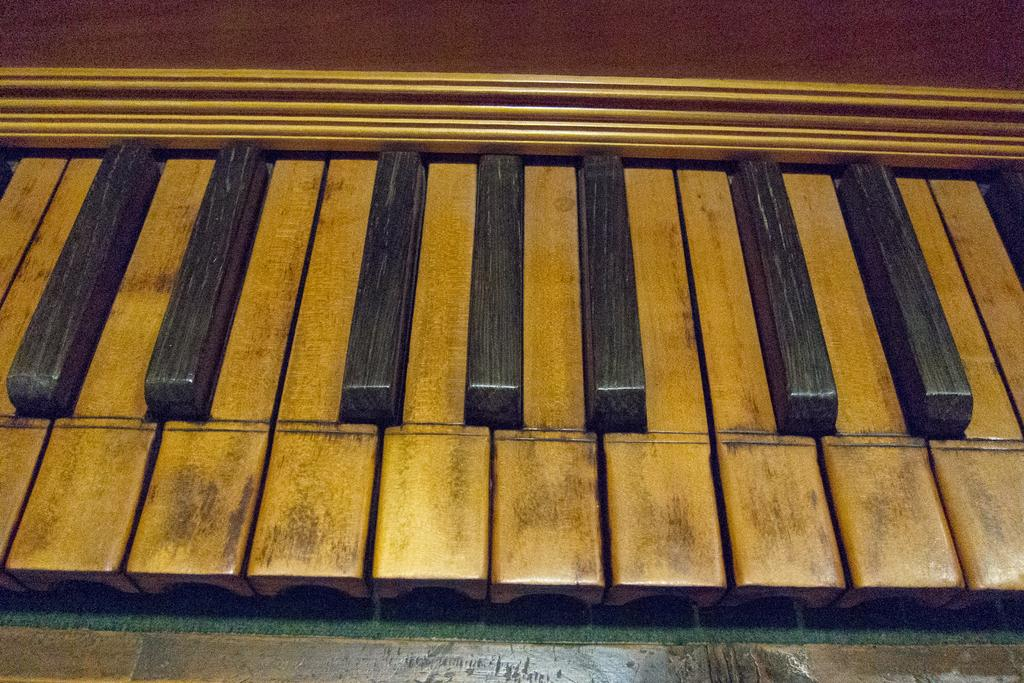What musical instrument can be seen in the image? There is a piano in the image. What material is the piano made of? The piano is made of wood. How does the growth of the kite affect the sound of the piano in the image? There is no kite present in the image, and therefore its growth cannot affect the sound of the piano. 